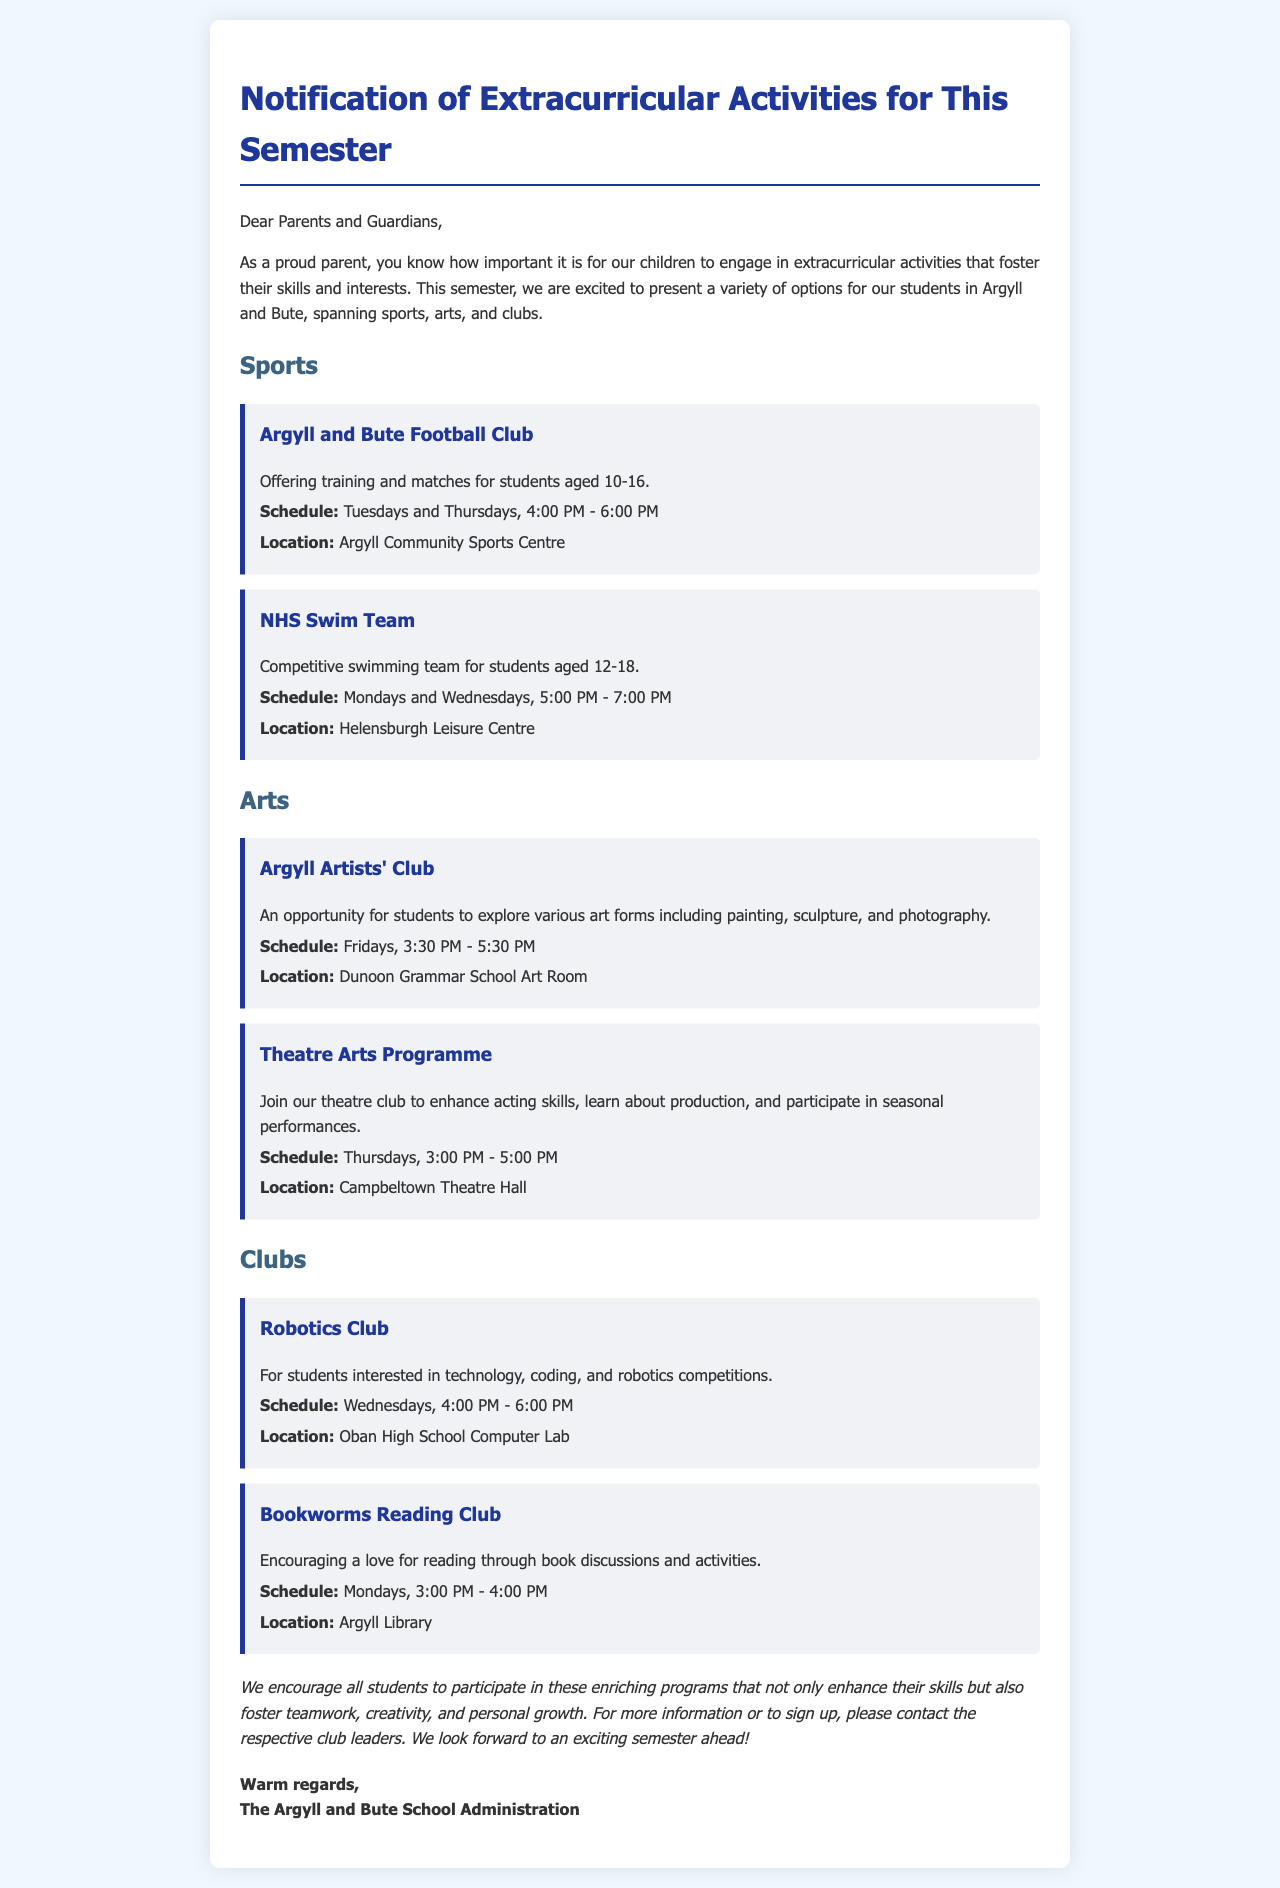What is the title of the document? The title of the document is indicated at the top of the letter.
Answer: Notification of Extracurricular Activities for This Semester What are the days for the Argyll and Bute Football Club? The schedule specifies the days of the football club's activities.
Answer: Tuesdays and Thursdays Who can join the NHS Swim Team? The eligibility for the swim team is mentioned in the activity description.
Answer: Students aged 12-18 What time does the Theatre Arts Programme start? The activity schedule provides the starting time for the theatre program.
Answer: 3:00 PM Where is the Robotics Club held? The location for the Robotics Club is noted in the description of the activity.
Answer: Oban High School Computer Lab What is the main focus of the Bookworms Reading Club? The description explains the purpose of the reading club.
Answer: Encouraging a love for reading How often does the Argyll Artists' Club meet? The schedule indicates the frequency of meetings for the art club.
Answer: Weekly (Fridays) What is the main benefit of participating in extracurricular activities? The closing paragraph highlights the benefits of these activities.
Answer: Enhance skills and foster teamwork Who sent the letter? The signature at the end identifies the sender of the document.
Answer: The Argyll and Bute School Administration 